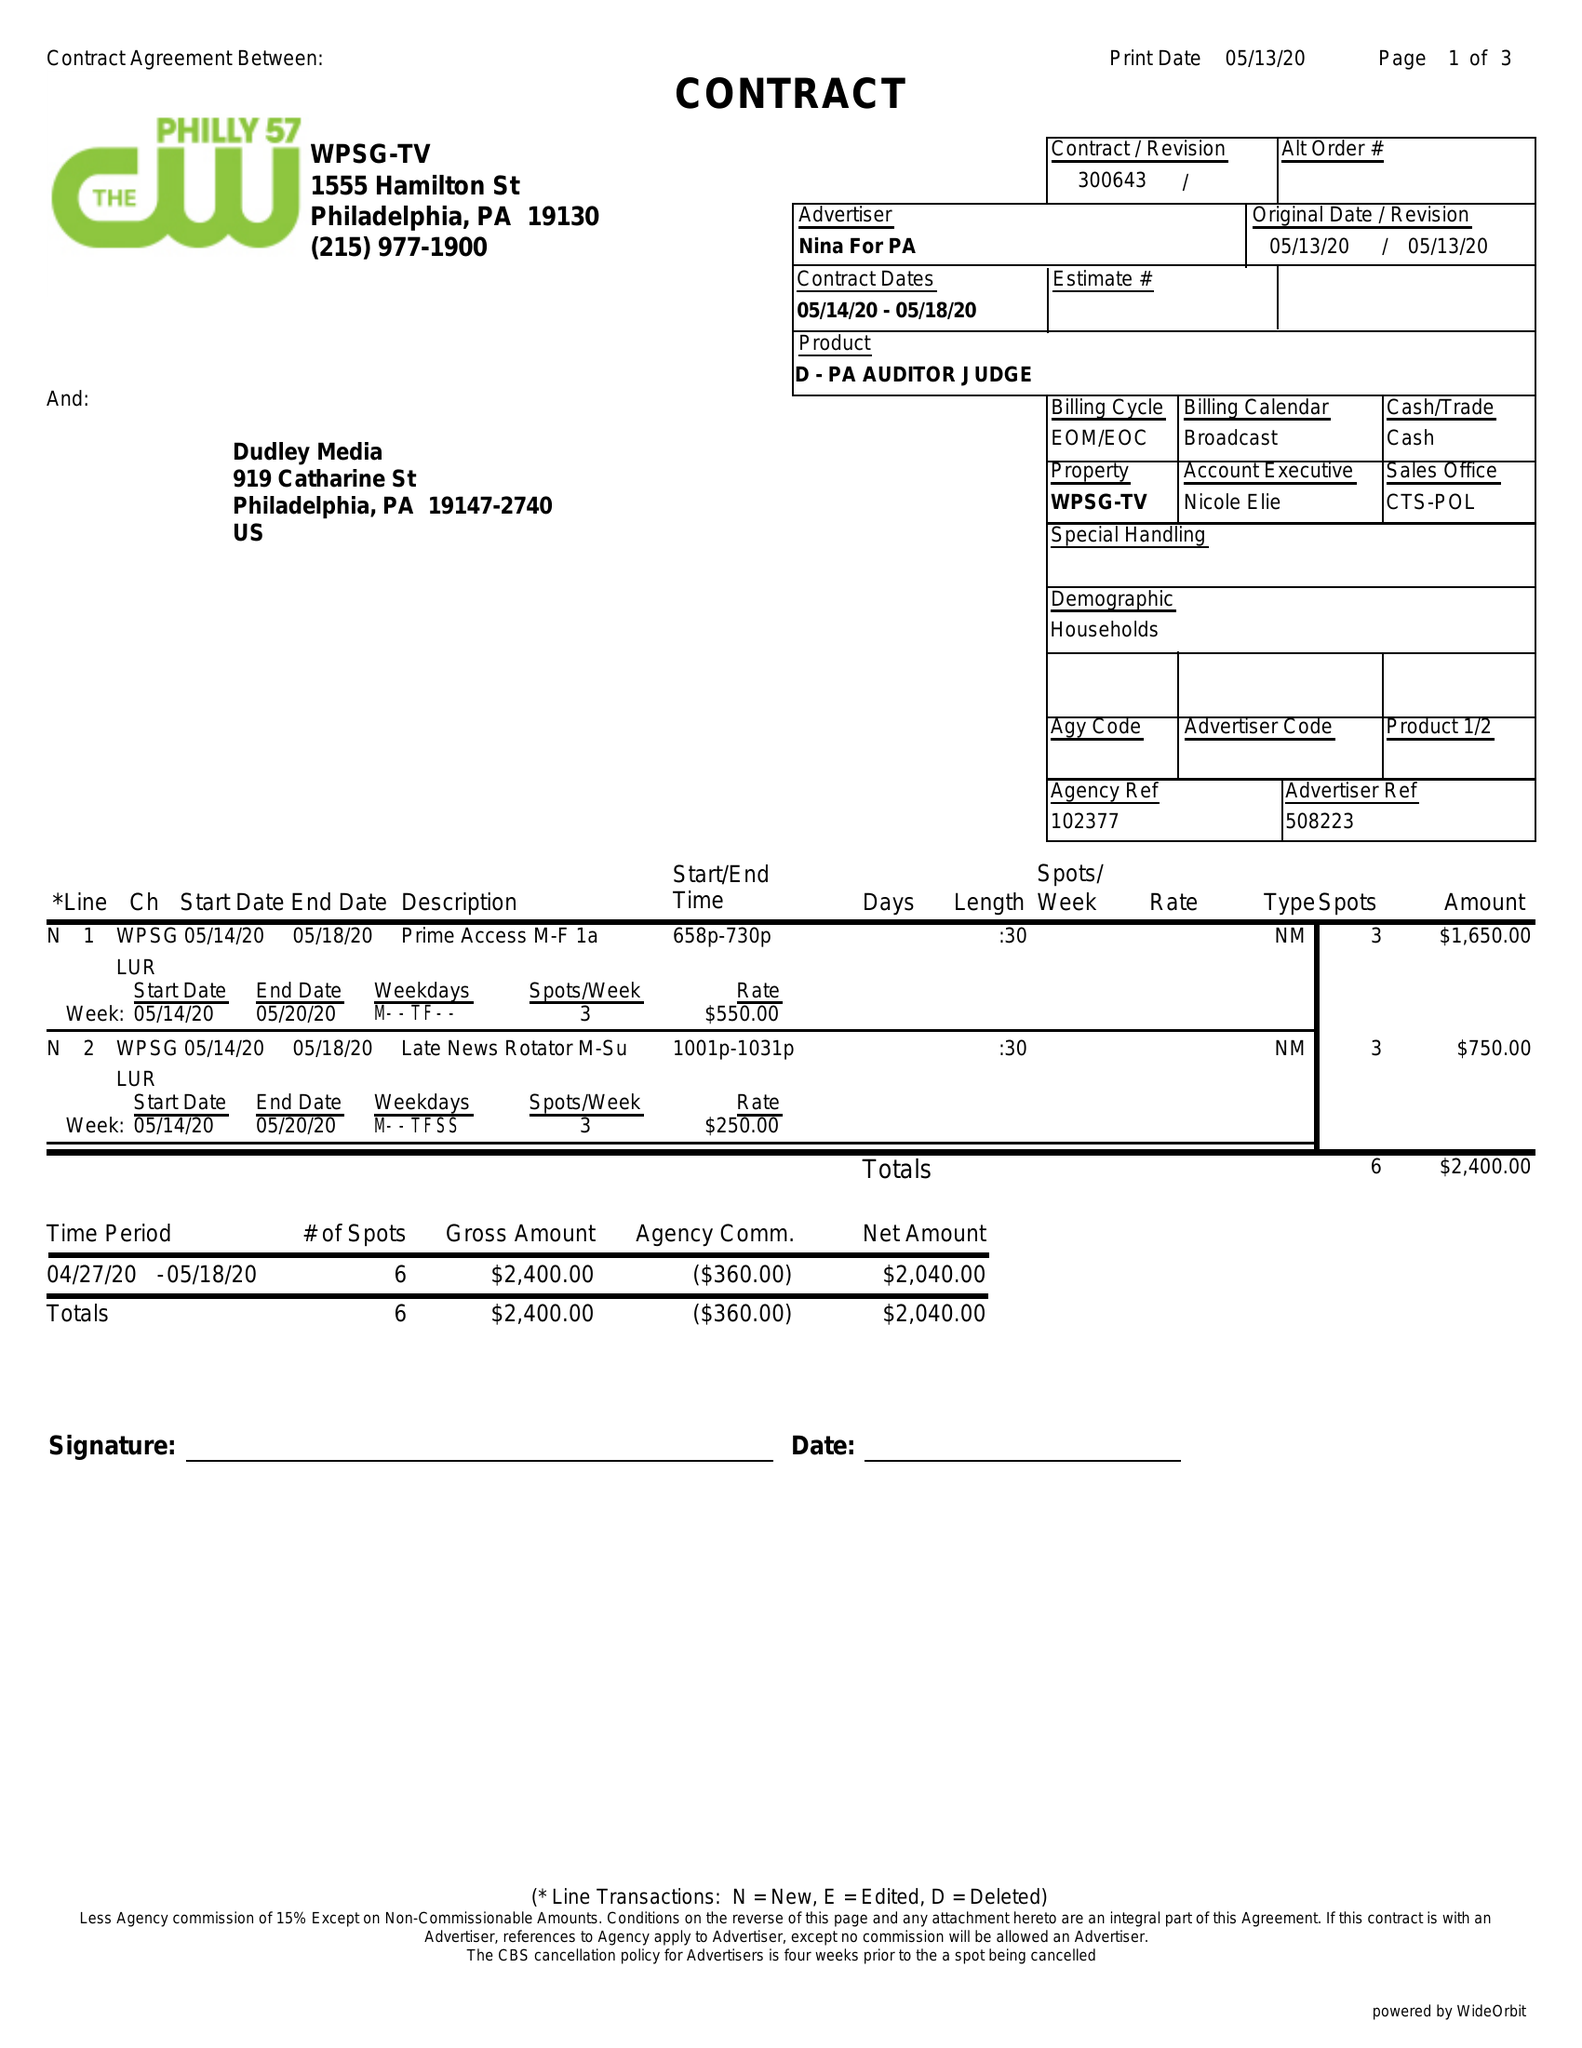What is the value for the advertiser?
Answer the question using a single word or phrase. NINA FOR PA 